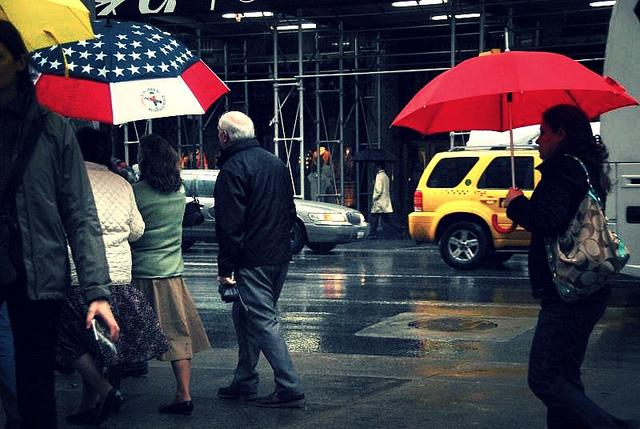One of the umbrellas is inspired by which country's flag? Please explain your reasoning. usa. The umbrella beside the yellow one has stars and red and white stripes. 